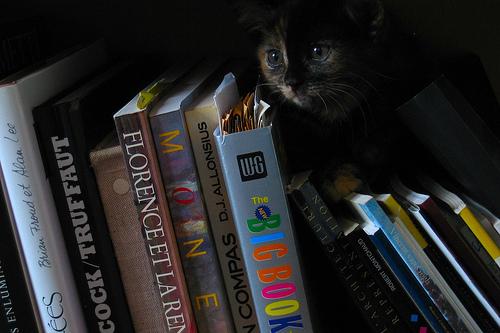Are these novels?
Keep it brief. Yes. Can you see a face in the shadows?
Answer briefly. Yes. Are the books facing the same way?
Answer briefly. No. 